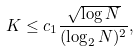<formula> <loc_0><loc_0><loc_500><loc_500>K \leq c _ { 1 } \frac { \sqrt { \log N } } { ( \log _ { 2 } N ) ^ { 2 } } ,</formula> 